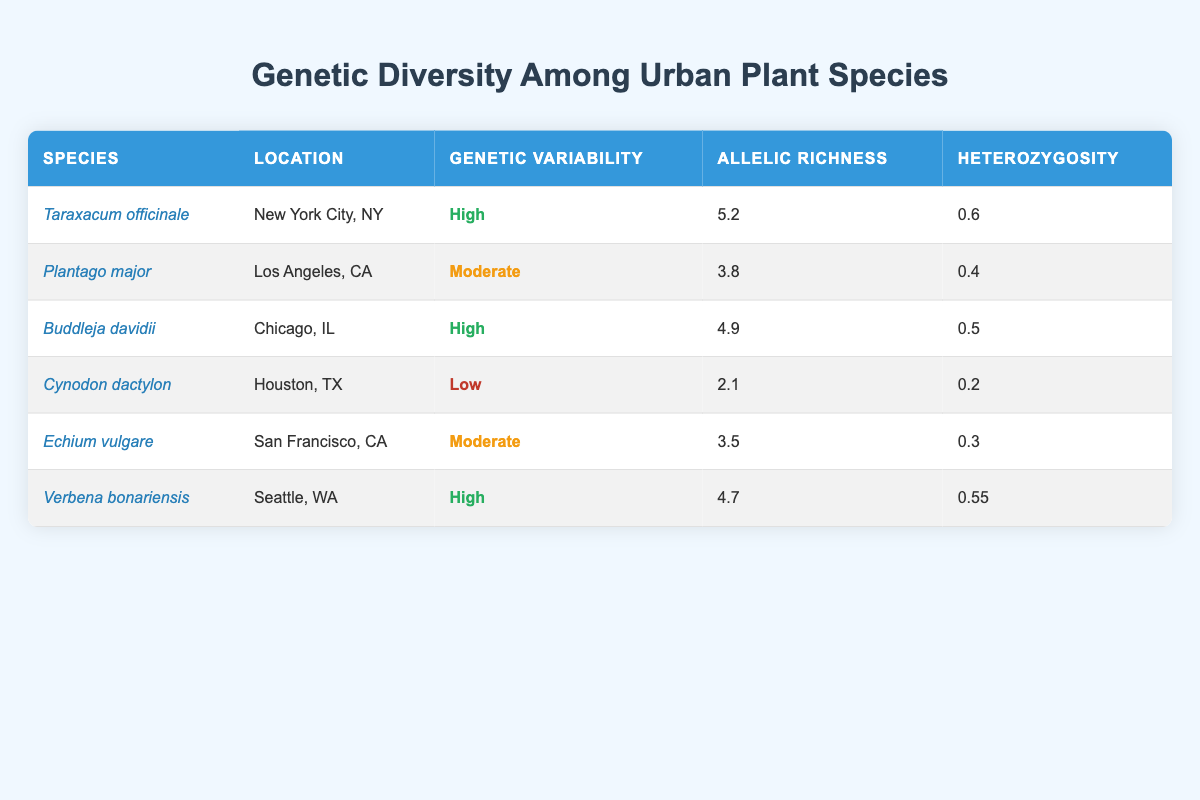What is the heterozygosity of Taraxacum officinale? The table indicates that the heterozygosity value for Taraxacum officinale, located in New York City, NY, is 0.6.
Answer: 0.6 Which species has the highest allelic richness? By examining the table, Taraxacum officinale has the highest allelic richness value of 5.2 among the listed species.
Answer: Taraxacum officinale Is the genetic variability of Cynodon dactylon high? The table shows that Cynodon dactylon, located in Houston, TX, has a genetic variability classified as low.
Answer: No What is the average heterozygosity of species with high genetic variability? Only three species have high genetic variability: Taraxacum officinale (0.6), Buddleja davidii (0.5), and Verbena bonariensis (0.55). To calculate the average, we sum these values: 0.6 + 0.5 + 0.55 = 1.65. Then, we divide by the number of species (3). Thus, the average is 1.65 / 3 = 0.55.
Answer: 0.55 List the plant species with moderate genetic variability and their locations. The table shows that Plantago major is located in Los Angeles, CA and Echium vulgare is located in San Francisco, CA. These are the two species with moderate genetic variability.
Answer: Plantago major in Los Angeles, CA; Echium vulgare in San Francisco, CA Which city has a plant species with the lowest allelic richness? From the data, Cynodon dactylon located in Houston, TX has the lowest allelic richness of 2.1.
Answer: Houston, TX How many species have an allelic richness greater than 4? In the table, we can see that Taraxacum officinale (5.2), Buddleja davidii (4.9), and Verbena bonariensis (4.7) all have allelic richness values greater than 4. That totals to three species.
Answer: 3 Is the genetic variability of Verbena bonariensis high? According to the table, Verbena bonariensis has a genetic variability classified as high, confirming that it indeed is.
Answer: Yes Which species have a genetic variability of moderate or greater? The species with moderate or greater genetic variability are Taraxacum officinale, Buddleja davidii, Verbena bonariensis, and Plantago major and Echium vulgare (which are assessed as moderate). This results in a total of five species.
Answer: 5 